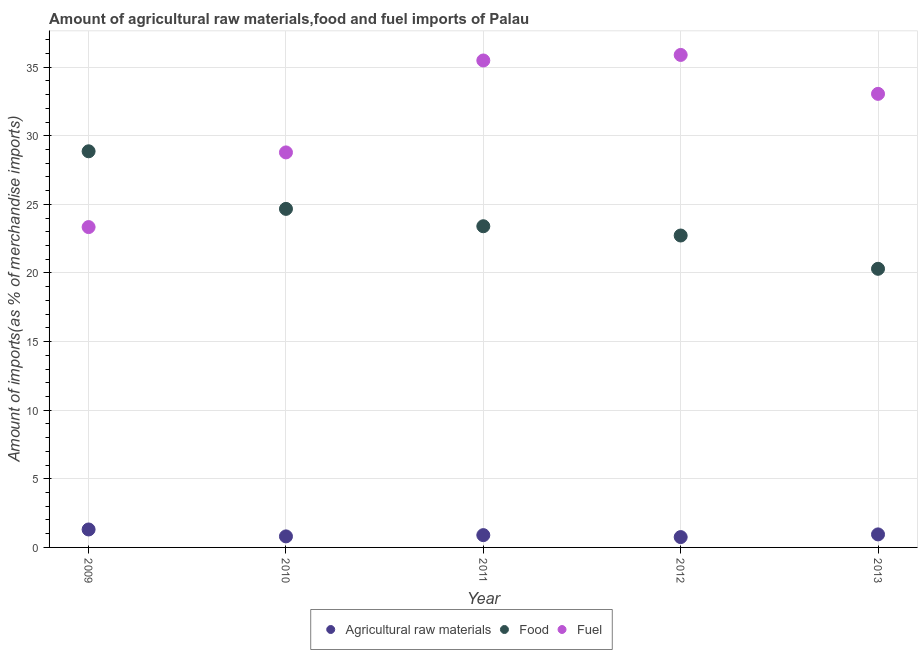Is the number of dotlines equal to the number of legend labels?
Your response must be concise. Yes. What is the percentage of raw materials imports in 2013?
Your response must be concise. 0.95. Across all years, what is the maximum percentage of food imports?
Offer a very short reply. 28.87. Across all years, what is the minimum percentage of food imports?
Provide a succinct answer. 20.3. In which year was the percentage of fuel imports minimum?
Offer a very short reply. 2009. What is the total percentage of food imports in the graph?
Give a very brief answer. 119.97. What is the difference between the percentage of raw materials imports in 2010 and that in 2013?
Provide a short and direct response. -0.15. What is the difference between the percentage of raw materials imports in 2011 and the percentage of food imports in 2009?
Offer a very short reply. -27.97. What is the average percentage of raw materials imports per year?
Your answer should be very brief. 0.94. In the year 2011, what is the difference between the percentage of raw materials imports and percentage of food imports?
Make the answer very short. -22.51. What is the ratio of the percentage of food imports in 2010 to that in 2011?
Your response must be concise. 1.05. Is the difference between the percentage of food imports in 2010 and 2012 greater than the difference between the percentage of fuel imports in 2010 and 2012?
Make the answer very short. Yes. What is the difference between the highest and the second highest percentage of raw materials imports?
Your response must be concise. 0.36. What is the difference between the highest and the lowest percentage of raw materials imports?
Make the answer very short. 0.55. Is it the case that in every year, the sum of the percentage of raw materials imports and percentage of food imports is greater than the percentage of fuel imports?
Provide a short and direct response. No. Is the percentage of raw materials imports strictly less than the percentage of fuel imports over the years?
Give a very brief answer. Yes. How many dotlines are there?
Your answer should be very brief. 3. Are the values on the major ticks of Y-axis written in scientific E-notation?
Ensure brevity in your answer.  No. Where does the legend appear in the graph?
Your response must be concise. Bottom center. How are the legend labels stacked?
Offer a very short reply. Horizontal. What is the title of the graph?
Your response must be concise. Amount of agricultural raw materials,food and fuel imports of Palau. What is the label or title of the X-axis?
Offer a very short reply. Year. What is the label or title of the Y-axis?
Provide a succinct answer. Amount of imports(as % of merchandise imports). What is the Amount of imports(as % of merchandise imports) in Agricultural raw materials in 2009?
Your response must be concise. 1.31. What is the Amount of imports(as % of merchandise imports) of Food in 2009?
Keep it short and to the point. 28.87. What is the Amount of imports(as % of merchandise imports) of Fuel in 2009?
Provide a succinct answer. 23.34. What is the Amount of imports(as % of merchandise imports) of Agricultural raw materials in 2010?
Your answer should be compact. 0.8. What is the Amount of imports(as % of merchandise imports) of Food in 2010?
Offer a terse response. 24.67. What is the Amount of imports(as % of merchandise imports) in Fuel in 2010?
Your answer should be compact. 28.78. What is the Amount of imports(as % of merchandise imports) of Agricultural raw materials in 2011?
Keep it short and to the point. 0.9. What is the Amount of imports(as % of merchandise imports) in Food in 2011?
Make the answer very short. 23.4. What is the Amount of imports(as % of merchandise imports) in Fuel in 2011?
Provide a short and direct response. 35.48. What is the Amount of imports(as % of merchandise imports) in Agricultural raw materials in 2012?
Ensure brevity in your answer.  0.75. What is the Amount of imports(as % of merchandise imports) in Food in 2012?
Offer a very short reply. 22.73. What is the Amount of imports(as % of merchandise imports) of Fuel in 2012?
Your answer should be very brief. 35.89. What is the Amount of imports(as % of merchandise imports) of Agricultural raw materials in 2013?
Your response must be concise. 0.95. What is the Amount of imports(as % of merchandise imports) in Food in 2013?
Your response must be concise. 20.3. What is the Amount of imports(as % of merchandise imports) in Fuel in 2013?
Ensure brevity in your answer.  33.05. Across all years, what is the maximum Amount of imports(as % of merchandise imports) in Agricultural raw materials?
Offer a very short reply. 1.31. Across all years, what is the maximum Amount of imports(as % of merchandise imports) in Food?
Keep it short and to the point. 28.87. Across all years, what is the maximum Amount of imports(as % of merchandise imports) of Fuel?
Give a very brief answer. 35.89. Across all years, what is the minimum Amount of imports(as % of merchandise imports) of Agricultural raw materials?
Offer a very short reply. 0.75. Across all years, what is the minimum Amount of imports(as % of merchandise imports) in Food?
Make the answer very short. 20.3. Across all years, what is the minimum Amount of imports(as % of merchandise imports) of Fuel?
Offer a terse response. 23.34. What is the total Amount of imports(as % of merchandise imports) in Agricultural raw materials in the graph?
Your answer should be compact. 4.71. What is the total Amount of imports(as % of merchandise imports) in Food in the graph?
Offer a very short reply. 119.97. What is the total Amount of imports(as % of merchandise imports) in Fuel in the graph?
Make the answer very short. 156.55. What is the difference between the Amount of imports(as % of merchandise imports) in Agricultural raw materials in 2009 and that in 2010?
Your answer should be compact. 0.5. What is the difference between the Amount of imports(as % of merchandise imports) of Food in 2009 and that in 2010?
Give a very brief answer. 4.2. What is the difference between the Amount of imports(as % of merchandise imports) in Fuel in 2009 and that in 2010?
Provide a short and direct response. -5.44. What is the difference between the Amount of imports(as % of merchandise imports) of Agricultural raw materials in 2009 and that in 2011?
Make the answer very short. 0.41. What is the difference between the Amount of imports(as % of merchandise imports) in Food in 2009 and that in 2011?
Ensure brevity in your answer.  5.46. What is the difference between the Amount of imports(as % of merchandise imports) of Fuel in 2009 and that in 2011?
Offer a very short reply. -12.14. What is the difference between the Amount of imports(as % of merchandise imports) of Agricultural raw materials in 2009 and that in 2012?
Provide a succinct answer. 0.56. What is the difference between the Amount of imports(as % of merchandise imports) in Food in 2009 and that in 2012?
Give a very brief answer. 6.14. What is the difference between the Amount of imports(as % of merchandise imports) in Fuel in 2009 and that in 2012?
Your answer should be very brief. -12.54. What is the difference between the Amount of imports(as % of merchandise imports) in Agricultural raw materials in 2009 and that in 2013?
Keep it short and to the point. 0.36. What is the difference between the Amount of imports(as % of merchandise imports) of Food in 2009 and that in 2013?
Make the answer very short. 8.56. What is the difference between the Amount of imports(as % of merchandise imports) of Fuel in 2009 and that in 2013?
Offer a terse response. -9.71. What is the difference between the Amount of imports(as % of merchandise imports) in Agricultural raw materials in 2010 and that in 2011?
Offer a very short reply. -0.09. What is the difference between the Amount of imports(as % of merchandise imports) of Food in 2010 and that in 2011?
Your answer should be compact. 1.27. What is the difference between the Amount of imports(as % of merchandise imports) of Fuel in 2010 and that in 2011?
Your response must be concise. -6.7. What is the difference between the Amount of imports(as % of merchandise imports) of Agricultural raw materials in 2010 and that in 2012?
Your response must be concise. 0.05. What is the difference between the Amount of imports(as % of merchandise imports) in Food in 2010 and that in 2012?
Your answer should be very brief. 1.94. What is the difference between the Amount of imports(as % of merchandise imports) in Fuel in 2010 and that in 2012?
Give a very brief answer. -7.1. What is the difference between the Amount of imports(as % of merchandise imports) of Agricultural raw materials in 2010 and that in 2013?
Offer a terse response. -0.15. What is the difference between the Amount of imports(as % of merchandise imports) in Food in 2010 and that in 2013?
Provide a short and direct response. 4.37. What is the difference between the Amount of imports(as % of merchandise imports) of Fuel in 2010 and that in 2013?
Offer a very short reply. -4.27. What is the difference between the Amount of imports(as % of merchandise imports) of Agricultural raw materials in 2011 and that in 2012?
Keep it short and to the point. 0.14. What is the difference between the Amount of imports(as % of merchandise imports) in Food in 2011 and that in 2012?
Make the answer very short. 0.68. What is the difference between the Amount of imports(as % of merchandise imports) in Fuel in 2011 and that in 2012?
Offer a terse response. -0.4. What is the difference between the Amount of imports(as % of merchandise imports) in Agricultural raw materials in 2011 and that in 2013?
Your response must be concise. -0.05. What is the difference between the Amount of imports(as % of merchandise imports) of Food in 2011 and that in 2013?
Your answer should be very brief. 3.1. What is the difference between the Amount of imports(as % of merchandise imports) in Fuel in 2011 and that in 2013?
Ensure brevity in your answer.  2.43. What is the difference between the Amount of imports(as % of merchandise imports) of Agricultural raw materials in 2012 and that in 2013?
Your answer should be very brief. -0.2. What is the difference between the Amount of imports(as % of merchandise imports) of Food in 2012 and that in 2013?
Provide a succinct answer. 2.43. What is the difference between the Amount of imports(as % of merchandise imports) of Fuel in 2012 and that in 2013?
Offer a terse response. 2.84. What is the difference between the Amount of imports(as % of merchandise imports) of Agricultural raw materials in 2009 and the Amount of imports(as % of merchandise imports) of Food in 2010?
Give a very brief answer. -23.36. What is the difference between the Amount of imports(as % of merchandise imports) of Agricultural raw materials in 2009 and the Amount of imports(as % of merchandise imports) of Fuel in 2010?
Provide a succinct answer. -27.48. What is the difference between the Amount of imports(as % of merchandise imports) in Food in 2009 and the Amount of imports(as % of merchandise imports) in Fuel in 2010?
Provide a succinct answer. 0.08. What is the difference between the Amount of imports(as % of merchandise imports) in Agricultural raw materials in 2009 and the Amount of imports(as % of merchandise imports) in Food in 2011?
Give a very brief answer. -22.1. What is the difference between the Amount of imports(as % of merchandise imports) in Agricultural raw materials in 2009 and the Amount of imports(as % of merchandise imports) in Fuel in 2011?
Make the answer very short. -34.17. What is the difference between the Amount of imports(as % of merchandise imports) of Food in 2009 and the Amount of imports(as % of merchandise imports) of Fuel in 2011?
Provide a short and direct response. -6.62. What is the difference between the Amount of imports(as % of merchandise imports) of Agricultural raw materials in 2009 and the Amount of imports(as % of merchandise imports) of Food in 2012?
Make the answer very short. -21.42. What is the difference between the Amount of imports(as % of merchandise imports) of Agricultural raw materials in 2009 and the Amount of imports(as % of merchandise imports) of Fuel in 2012?
Your response must be concise. -34.58. What is the difference between the Amount of imports(as % of merchandise imports) of Food in 2009 and the Amount of imports(as % of merchandise imports) of Fuel in 2012?
Offer a terse response. -7.02. What is the difference between the Amount of imports(as % of merchandise imports) of Agricultural raw materials in 2009 and the Amount of imports(as % of merchandise imports) of Food in 2013?
Your answer should be very brief. -18.99. What is the difference between the Amount of imports(as % of merchandise imports) of Agricultural raw materials in 2009 and the Amount of imports(as % of merchandise imports) of Fuel in 2013?
Your answer should be compact. -31.74. What is the difference between the Amount of imports(as % of merchandise imports) of Food in 2009 and the Amount of imports(as % of merchandise imports) of Fuel in 2013?
Ensure brevity in your answer.  -4.18. What is the difference between the Amount of imports(as % of merchandise imports) in Agricultural raw materials in 2010 and the Amount of imports(as % of merchandise imports) in Food in 2011?
Offer a terse response. -22.6. What is the difference between the Amount of imports(as % of merchandise imports) of Agricultural raw materials in 2010 and the Amount of imports(as % of merchandise imports) of Fuel in 2011?
Give a very brief answer. -34.68. What is the difference between the Amount of imports(as % of merchandise imports) in Food in 2010 and the Amount of imports(as % of merchandise imports) in Fuel in 2011?
Ensure brevity in your answer.  -10.81. What is the difference between the Amount of imports(as % of merchandise imports) in Agricultural raw materials in 2010 and the Amount of imports(as % of merchandise imports) in Food in 2012?
Your answer should be very brief. -21.92. What is the difference between the Amount of imports(as % of merchandise imports) in Agricultural raw materials in 2010 and the Amount of imports(as % of merchandise imports) in Fuel in 2012?
Make the answer very short. -35.08. What is the difference between the Amount of imports(as % of merchandise imports) in Food in 2010 and the Amount of imports(as % of merchandise imports) in Fuel in 2012?
Ensure brevity in your answer.  -11.22. What is the difference between the Amount of imports(as % of merchandise imports) of Agricultural raw materials in 2010 and the Amount of imports(as % of merchandise imports) of Food in 2013?
Offer a terse response. -19.5. What is the difference between the Amount of imports(as % of merchandise imports) in Agricultural raw materials in 2010 and the Amount of imports(as % of merchandise imports) in Fuel in 2013?
Make the answer very short. -32.25. What is the difference between the Amount of imports(as % of merchandise imports) in Food in 2010 and the Amount of imports(as % of merchandise imports) in Fuel in 2013?
Provide a succinct answer. -8.38. What is the difference between the Amount of imports(as % of merchandise imports) of Agricultural raw materials in 2011 and the Amount of imports(as % of merchandise imports) of Food in 2012?
Make the answer very short. -21.83. What is the difference between the Amount of imports(as % of merchandise imports) in Agricultural raw materials in 2011 and the Amount of imports(as % of merchandise imports) in Fuel in 2012?
Your response must be concise. -34.99. What is the difference between the Amount of imports(as % of merchandise imports) of Food in 2011 and the Amount of imports(as % of merchandise imports) of Fuel in 2012?
Keep it short and to the point. -12.48. What is the difference between the Amount of imports(as % of merchandise imports) of Agricultural raw materials in 2011 and the Amount of imports(as % of merchandise imports) of Food in 2013?
Your answer should be very brief. -19.41. What is the difference between the Amount of imports(as % of merchandise imports) of Agricultural raw materials in 2011 and the Amount of imports(as % of merchandise imports) of Fuel in 2013?
Your answer should be compact. -32.15. What is the difference between the Amount of imports(as % of merchandise imports) in Food in 2011 and the Amount of imports(as % of merchandise imports) in Fuel in 2013?
Keep it short and to the point. -9.65. What is the difference between the Amount of imports(as % of merchandise imports) in Agricultural raw materials in 2012 and the Amount of imports(as % of merchandise imports) in Food in 2013?
Provide a short and direct response. -19.55. What is the difference between the Amount of imports(as % of merchandise imports) of Agricultural raw materials in 2012 and the Amount of imports(as % of merchandise imports) of Fuel in 2013?
Give a very brief answer. -32.3. What is the difference between the Amount of imports(as % of merchandise imports) in Food in 2012 and the Amount of imports(as % of merchandise imports) in Fuel in 2013?
Provide a short and direct response. -10.32. What is the average Amount of imports(as % of merchandise imports) of Agricultural raw materials per year?
Provide a short and direct response. 0.94. What is the average Amount of imports(as % of merchandise imports) of Food per year?
Your answer should be compact. 23.99. What is the average Amount of imports(as % of merchandise imports) in Fuel per year?
Provide a succinct answer. 31.31. In the year 2009, what is the difference between the Amount of imports(as % of merchandise imports) of Agricultural raw materials and Amount of imports(as % of merchandise imports) of Food?
Ensure brevity in your answer.  -27.56. In the year 2009, what is the difference between the Amount of imports(as % of merchandise imports) in Agricultural raw materials and Amount of imports(as % of merchandise imports) in Fuel?
Offer a very short reply. -22.03. In the year 2009, what is the difference between the Amount of imports(as % of merchandise imports) of Food and Amount of imports(as % of merchandise imports) of Fuel?
Your response must be concise. 5.52. In the year 2010, what is the difference between the Amount of imports(as % of merchandise imports) in Agricultural raw materials and Amount of imports(as % of merchandise imports) in Food?
Provide a succinct answer. -23.87. In the year 2010, what is the difference between the Amount of imports(as % of merchandise imports) of Agricultural raw materials and Amount of imports(as % of merchandise imports) of Fuel?
Your response must be concise. -27.98. In the year 2010, what is the difference between the Amount of imports(as % of merchandise imports) of Food and Amount of imports(as % of merchandise imports) of Fuel?
Offer a very short reply. -4.11. In the year 2011, what is the difference between the Amount of imports(as % of merchandise imports) in Agricultural raw materials and Amount of imports(as % of merchandise imports) in Food?
Provide a succinct answer. -22.51. In the year 2011, what is the difference between the Amount of imports(as % of merchandise imports) of Agricultural raw materials and Amount of imports(as % of merchandise imports) of Fuel?
Ensure brevity in your answer.  -34.59. In the year 2011, what is the difference between the Amount of imports(as % of merchandise imports) in Food and Amount of imports(as % of merchandise imports) in Fuel?
Your answer should be very brief. -12.08. In the year 2012, what is the difference between the Amount of imports(as % of merchandise imports) of Agricultural raw materials and Amount of imports(as % of merchandise imports) of Food?
Offer a terse response. -21.98. In the year 2012, what is the difference between the Amount of imports(as % of merchandise imports) in Agricultural raw materials and Amount of imports(as % of merchandise imports) in Fuel?
Your answer should be very brief. -35.13. In the year 2012, what is the difference between the Amount of imports(as % of merchandise imports) in Food and Amount of imports(as % of merchandise imports) in Fuel?
Make the answer very short. -13.16. In the year 2013, what is the difference between the Amount of imports(as % of merchandise imports) in Agricultural raw materials and Amount of imports(as % of merchandise imports) in Food?
Offer a very short reply. -19.35. In the year 2013, what is the difference between the Amount of imports(as % of merchandise imports) of Agricultural raw materials and Amount of imports(as % of merchandise imports) of Fuel?
Ensure brevity in your answer.  -32.1. In the year 2013, what is the difference between the Amount of imports(as % of merchandise imports) of Food and Amount of imports(as % of merchandise imports) of Fuel?
Your answer should be compact. -12.75. What is the ratio of the Amount of imports(as % of merchandise imports) of Agricultural raw materials in 2009 to that in 2010?
Your answer should be very brief. 1.63. What is the ratio of the Amount of imports(as % of merchandise imports) of Food in 2009 to that in 2010?
Your answer should be compact. 1.17. What is the ratio of the Amount of imports(as % of merchandise imports) of Fuel in 2009 to that in 2010?
Ensure brevity in your answer.  0.81. What is the ratio of the Amount of imports(as % of merchandise imports) in Agricultural raw materials in 2009 to that in 2011?
Offer a terse response. 1.46. What is the ratio of the Amount of imports(as % of merchandise imports) of Food in 2009 to that in 2011?
Your answer should be compact. 1.23. What is the ratio of the Amount of imports(as % of merchandise imports) in Fuel in 2009 to that in 2011?
Give a very brief answer. 0.66. What is the ratio of the Amount of imports(as % of merchandise imports) in Agricultural raw materials in 2009 to that in 2012?
Your response must be concise. 1.74. What is the ratio of the Amount of imports(as % of merchandise imports) of Food in 2009 to that in 2012?
Your answer should be compact. 1.27. What is the ratio of the Amount of imports(as % of merchandise imports) in Fuel in 2009 to that in 2012?
Provide a succinct answer. 0.65. What is the ratio of the Amount of imports(as % of merchandise imports) in Agricultural raw materials in 2009 to that in 2013?
Your answer should be very brief. 1.38. What is the ratio of the Amount of imports(as % of merchandise imports) of Food in 2009 to that in 2013?
Your answer should be very brief. 1.42. What is the ratio of the Amount of imports(as % of merchandise imports) in Fuel in 2009 to that in 2013?
Your response must be concise. 0.71. What is the ratio of the Amount of imports(as % of merchandise imports) of Agricultural raw materials in 2010 to that in 2011?
Offer a very short reply. 0.9. What is the ratio of the Amount of imports(as % of merchandise imports) in Food in 2010 to that in 2011?
Provide a short and direct response. 1.05. What is the ratio of the Amount of imports(as % of merchandise imports) of Fuel in 2010 to that in 2011?
Ensure brevity in your answer.  0.81. What is the ratio of the Amount of imports(as % of merchandise imports) of Agricultural raw materials in 2010 to that in 2012?
Your answer should be very brief. 1.07. What is the ratio of the Amount of imports(as % of merchandise imports) of Food in 2010 to that in 2012?
Give a very brief answer. 1.09. What is the ratio of the Amount of imports(as % of merchandise imports) in Fuel in 2010 to that in 2012?
Make the answer very short. 0.8. What is the ratio of the Amount of imports(as % of merchandise imports) in Agricultural raw materials in 2010 to that in 2013?
Provide a short and direct response. 0.85. What is the ratio of the Amount of imports(as % of merchandise imports) in Food in 2010 to that in 2013?
Provide a short and direct response. 1.22. What is the ratio of the Amount of imports(as % of merchandise imports) of Fuel in 2010 to that in 2013?
Offer a terse response. 0.87. What is the ratio of the Amount of imports(as % of merchandise imports) in Agricultural raw materials in 2011 to that in 2012?
Give a very brief answer. 1.19. What is the ratio of the Amount of imports(as % of merchandise imports) in Food in 2011 to that in 2012?
Give a very brief answer. 1.03. What is the ratio of the Amount of imports(as % of merchandise imports) of Fuel in 2011 to that in 2012?
Provide a short and direct response. 0.99. What is the ratio of the Amount of imports(as % of merchandise imports) in Agricultural raw materials in 2011 to that in 2013?
Give a very brief answer. 0.94. What is the ratio of the Amount of imports(as % of merchandise imports) of Food in 2011 to that in 2013?
Offer a terse response. 1.15. What is the ratio of the Amount of imports(as % of merchandise imports) in Fuel in 2011 to that in 2013?
Make the answer very short. 1.07. What is the ratio of the Amount of imports(as % of merchandise imports) in Agricultural raw materials in 2012 to that in 2013?
Give a very brief answer. 0.79. What is the ratio of the Amount of imports(as % of merchandise imports) of Food in 2012 to that in 2013?
Provide a short and direct response. 1.12. What is the ratio of the Amount of imports(as % of merchandise imports) in Fuel in 2012 to that in 2013?
Your answer should be compact. 1.09. What is the difference between the highest and the second highest Amount of imports(as % of merchandise imports) in Agricultural raw materials?
Keep it short and to the point. 0.36. What is the difference between the highest and the second highest Amount of imports(as % of merchandise imports) in Food?
Your response must be concise. 4.2. What is the difference between the highest and the second highest Amount of imports(as % of merchandise imports) of Fuel?
Make the answer very short. 0.4. What is the difference between the highest and the lowest Amount of imports(as % of merchandise imports) in Agricultural raw materials?
Ensure brevity in your answer.  0.56. What is the difference between the highest and the lowest Amount of imports(as % of merchandise imports) of Food?
Keep it short and to the point. 8.56. What is the difference between the highest and the lowest Amount of imports(as % of merchandise imports) of Fuel?
Your answer should be very brief. 12.54. 